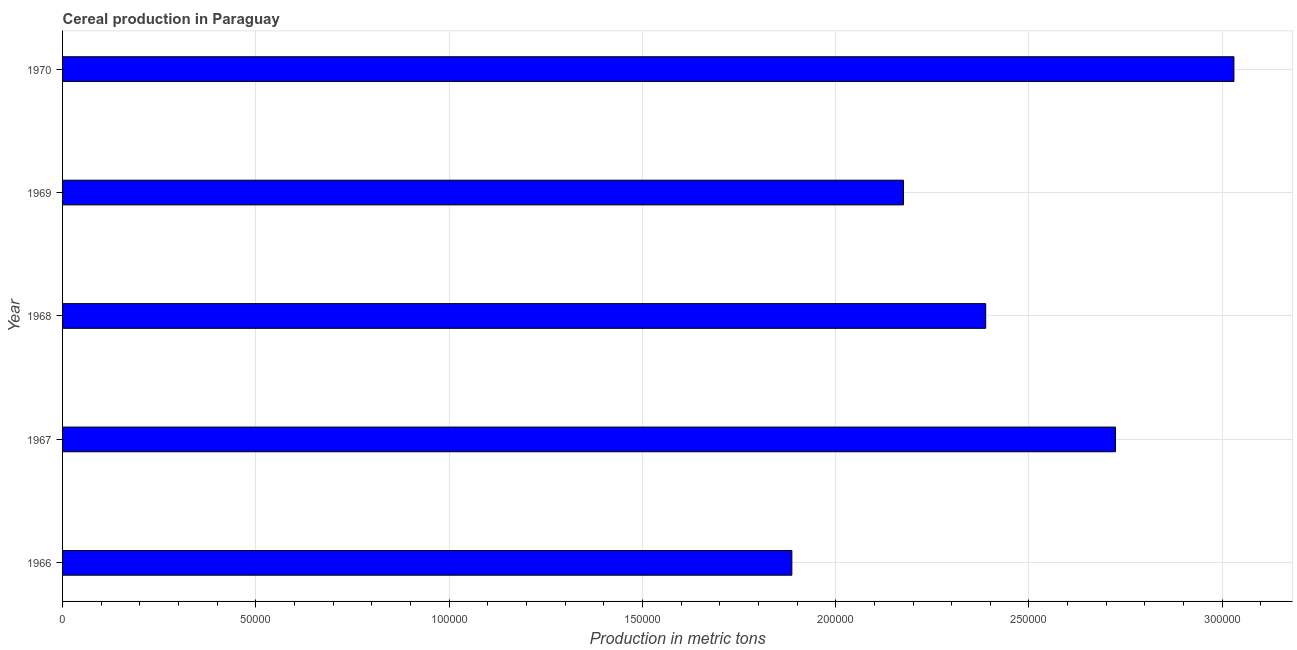Does the graph contain grids?
Ensure brevity in your answer.  Yes. What is the title of the graph?
Your response must be concise. Cereal production in Paraguay. What is the label or title of the X-axis?
Your response must be concise. Production in metric tons. What is the label or title of the Y-axis?
Your response must be concise. Year. What is the cereal production in 1966?
Your response must be concise. 1.89e+05. Across all years, what is the maximum cereal production?
Make the answer very short. 3.03e+05. Across all years, what is the minimum cereal production?
Give a very brief answer. 1.89e+05. In which year was the cereal production minimum?
Make the answer very short. 1966. What is the sum of the cereal production?
Your answer should be very brief. 1.22e+06. What is the difference between the cereal production in 1966 and 1969?
Your response must be concise. -2.89e+04. What is the average cereal production per year?
Provide a short and direct response. 2.44e+05. What is the median cereal production?
Provide a short and direct response. 2.39e+05. In how many years, is the cereal production greater than 230000 metric tons?
Offer a very short reply. 3. Do a majority of the years between 1966 and 1969 (inclusive) have cereal production greater than 100000 metric tons?
Your answer should be very brief. Yes. What is the ratio of the cereal production in 1966 to that in 1968?
Make the answer very short. 0.79. What is the difference between the highest and the second highest cereal production?
Your answer should be very brief. 3.06e+04. What is the difference between the highest and the lowest cereal production?
Make the answer very short. 1.14e+05. In how many years, is the cereal production greater than the average cereal production taken over all years?
Offer a terse response. 2. How many bars are there?
Your response must be concise. 5. How many years are there in the graph?
Provide a succinct answer. 5. Are the values on the major ticks of X-axis written in scientific E-notation?
Give a very brief answer. No. What is the Production in metric tons of 1966?
Give a very brief answer. 1.89e+05. What is the Production in metric tons of 1967?
Your answer should be compact. 2.72e+05. What is the Production in metric tons of 1968?
Offer a terse response. 2.39e+05. What is the Production in metric tons in 1969?
Ensure brevity in your answer.  2.18e+05. What is the Production in metric tons of 1970?
Provide a short and direct response. 3.03e+05. What is the difference between the Production in metric tons in 1966 and 1967?
Your response must be concise. -8.37e+04. What is the difference between the Production in metric tons in 1966 and 1968?
Offer a very short reply. -5.01e+04. What is the difference between the Production in metric tons in 1966 and 1969?
Offer a very short reply. -2.89e+04. What is the difference between the Production in metric tons in 1966 and 1970?
Give a very brief answer. -1.14e+05. What is the difference between the Production in metric tons in 1967 and 1968?
Keep it short and to the point. 3.36e+04. What is the difference between the Production in metric tons in 1967 and 1969?
Provide a succinct answer. 5.48e+04. What is the difference between the Production in metric tons in 1967 and 1970?
Your answer should be compact. -3.06e+04. What is the difference between the Production in metric tons in 1968 and 1969?
Your answer should be compact. 2.13e+04. What is the difference between the Production in metric tons in 1968 and 1970?
Give a very brief answer. -6.42e+04. What is the difference between the Production in metric tons in 1969 and 1970?
Keep it short and to the point. -8.55e+04. What is the ratio of the Production in metric tons in 1966 to that in 1967?
Your response must be concise. 0.69. What is the ratio of the Production in metric tons in 1966 to that in 1968?
Keep it short and to the point. 0.79. What is the ratio of the Production in metric tons in 1966 to that in 1969?
Keep it short and to the point. 0.87. What is the ratio of the Production in metric tons in 1966 to that in 1970?
Offer a very short reply. 0.62. What is the ratio of the Production in metric tons in 1967 to that in 1968?
Your answer should be very brief. 1.14. What is the ratio of the Production in metric tons in 1967 to that in 1969?
Offer a terse response. 1.25. What is the ratio of the Production in metric tons in 1967 to that in 1970?
Ensure brevity in your answer.  0.9. What is the ratio of the Production in metric tons in 1968 to that in 1969?
Make the answer very short. 1.1. What is the ratio of the Production in metric tons in 1968 to that in 1970?
Provide a succinct answer. 0.79. What is the ratio of the Production in metric tons in 1969 to that in 1970?
Provide a short and direct response. 0.72. 